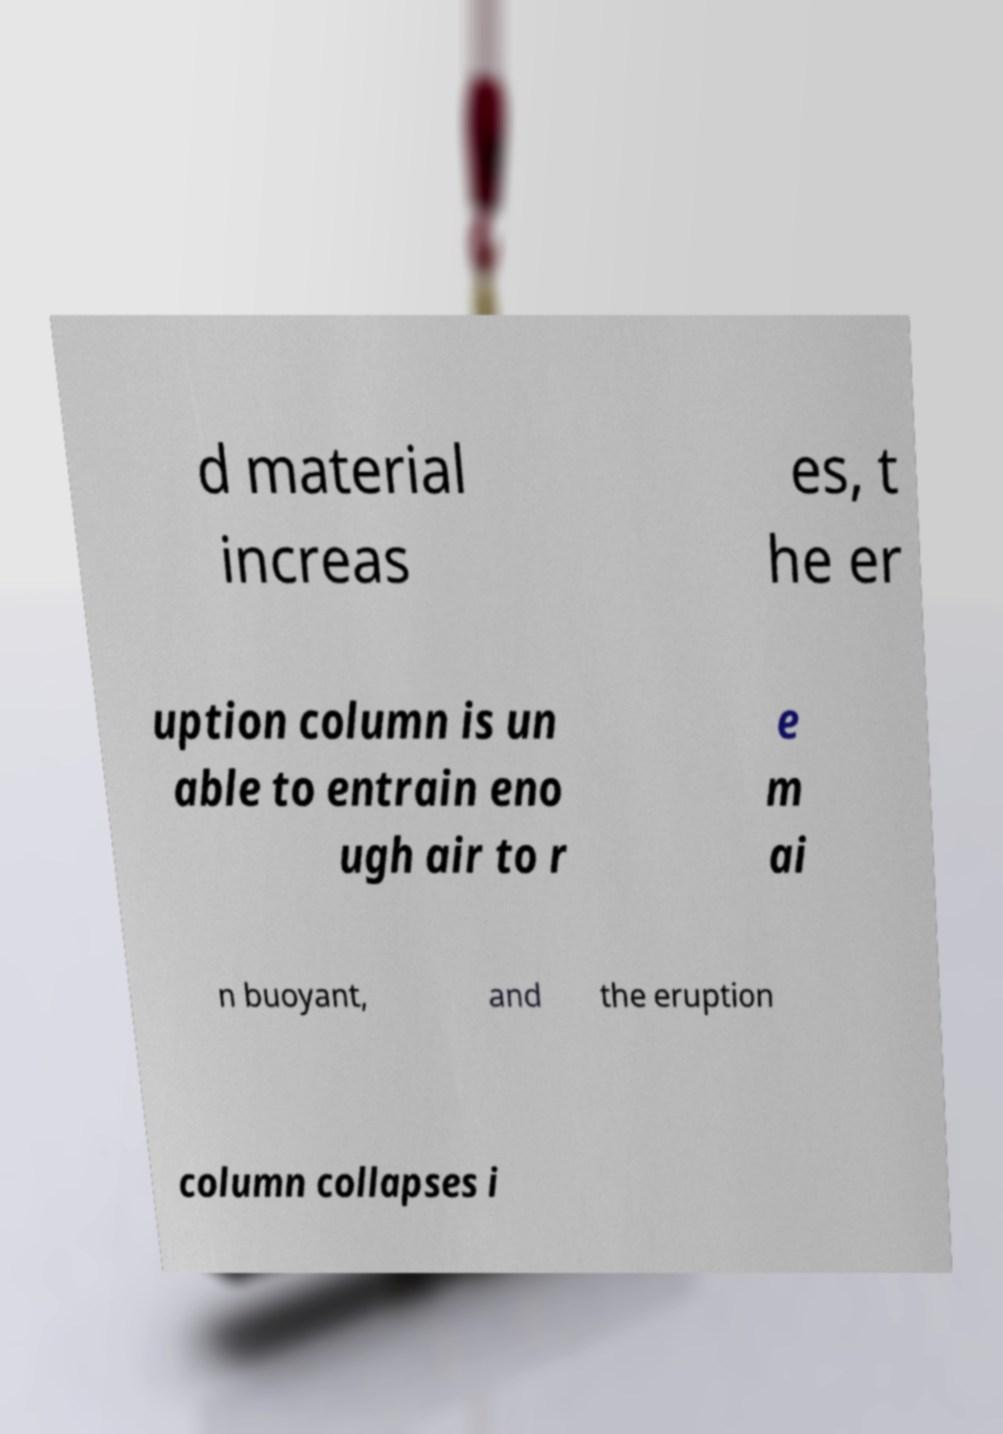Please identify and transcribe the text found in this image. d material increas es, t he er uption column is un able to entrain eno ugh air to r e m ai n buoyant, and the eruption column collapses i 